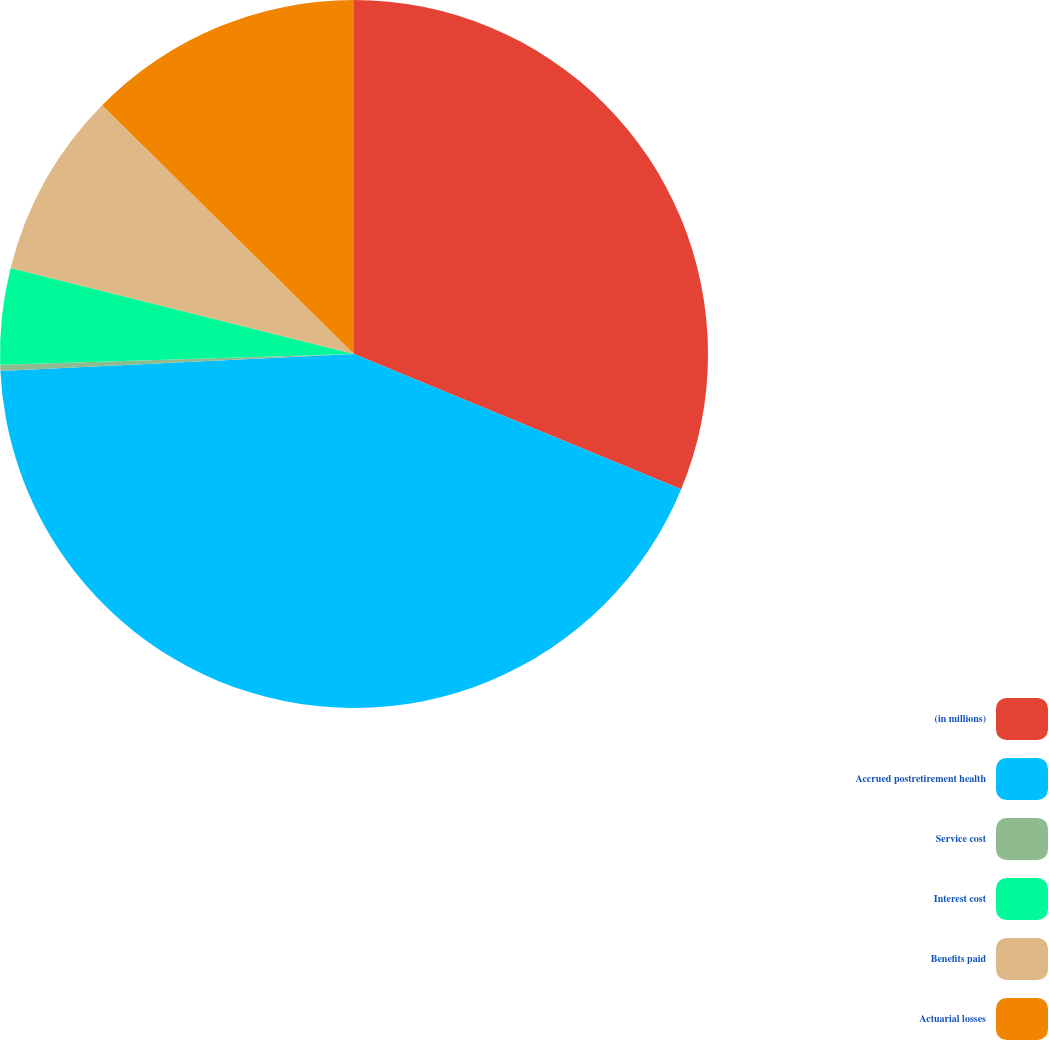Convert chart to OTSL. <chart><loc_0><loc_0><loc_500><loc_500><pie_chart><fcel>(in millions)<fcel>Accrued postretirement health<fcel>Service cost<fcel>Interest cost<fcel>Benefits paid<fcel>Actuarial losses<nl><fcel>31.24%<fcel>43.0%<fcel>0.28%<fcel>4.39%<fcel>8.49%<fcel>12.6%<nl></chart> 